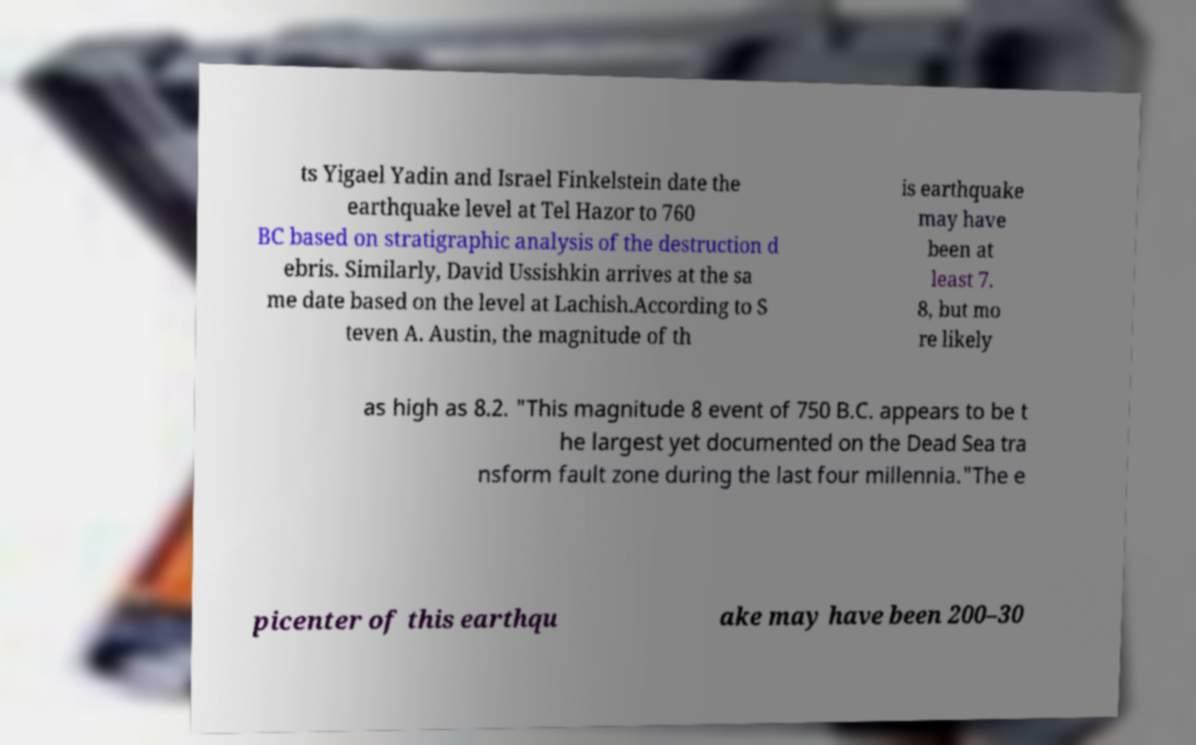Can you read and provide the text displayed in the image?This photo seems to have some interesting text. Can you extract and type it out for me? ts Yigael Yadin and Israel Finkelstein date the earthquake level at Tel Hazor to 760 BC based on stratigraphic analysis of the destruction d ebris. Similarly, David Ussishkin arrives at the sa me date based on the level at Lachish.According to S teven A. Austin, the magnitude of th is earthquake may have been at least 7. 8, but mo re likely as high as 8.2. "This magnitude 8 event of 750 B.C. appears to be t he largest yet documented on the Dead Sea tra nsform fault zone during the last four millennia."The e picenter of this earthqu ake may have been 200–30 